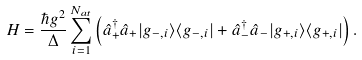<formula> <loc_0><loc_0><loc_500><loc_500>H = \frac { \hbar { g } ^ { 2 } } { \Delta } \sum _ { i = 1 } ^ { N _ { a t } } \left ( \hat { a } _ { + } ^ { \dag } \hat { a } _ { + } | g _ { - , i } \rangle \langle g _ { - , i } | + \hat { a } _ { - } ^ { \dag } \hat { a } _ { - } | g _ { + , i } \rangle \langle g _ { + , i } | \right ) .</formula> 